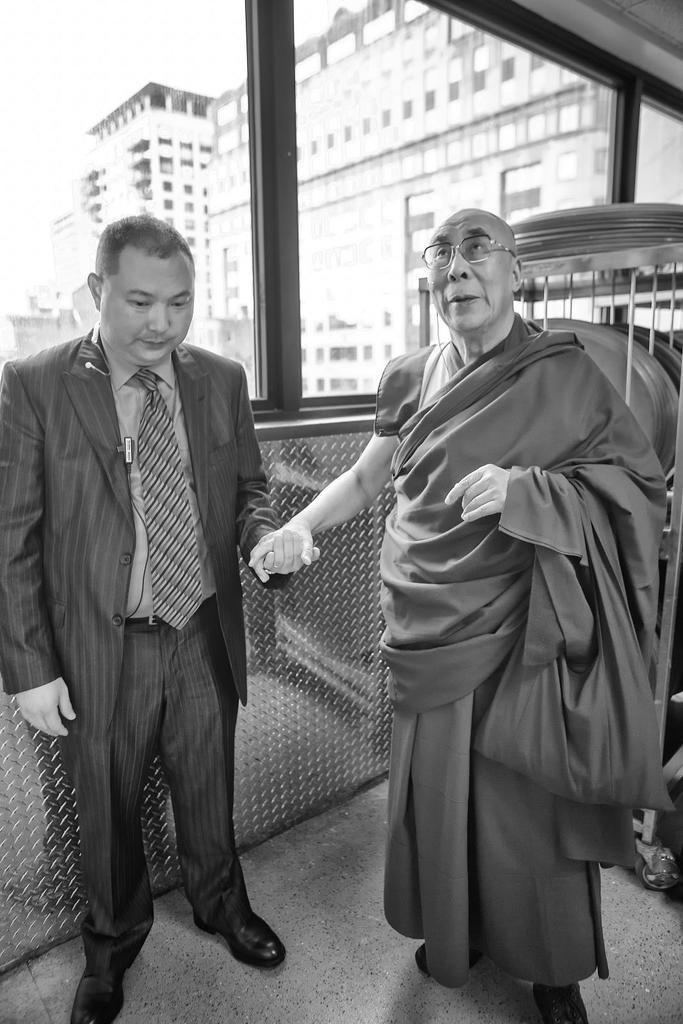How many people are present in the image? There are two persons standing in the image. What can be seen behind the people in the image? There is a glass window in the backdrop of the image. What is visible through the window? A building is visible through the window. What type of flowers can be seen growing near the lake in the image? There is no lake or flowers present in the image. 